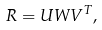<formula> <loc_0><loc_0><loc_500><loc_500>R = U W V ^ { T } ,</formula> 